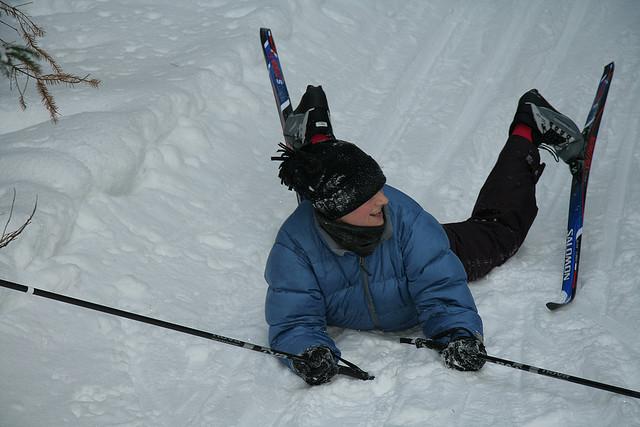Are they killing?
Keep it brief. No. Is this person moving quickly?
Concise answer only. No. Is he standing?
Write a very short answer. No. Is this person in pain?
Write a very short answer. No. 